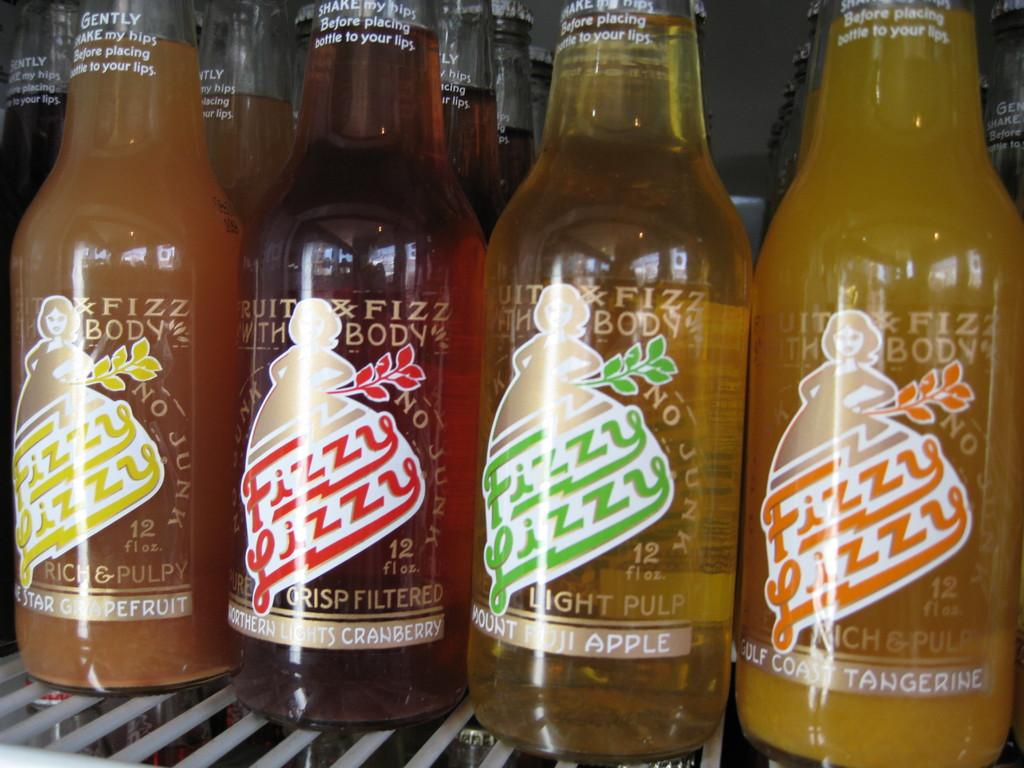<image>
Write a terse but informative summary of the picture. A collection of Fizzy Lizzy drinks in different flavors, such as Tangerine and Mount Fuji Apple. 